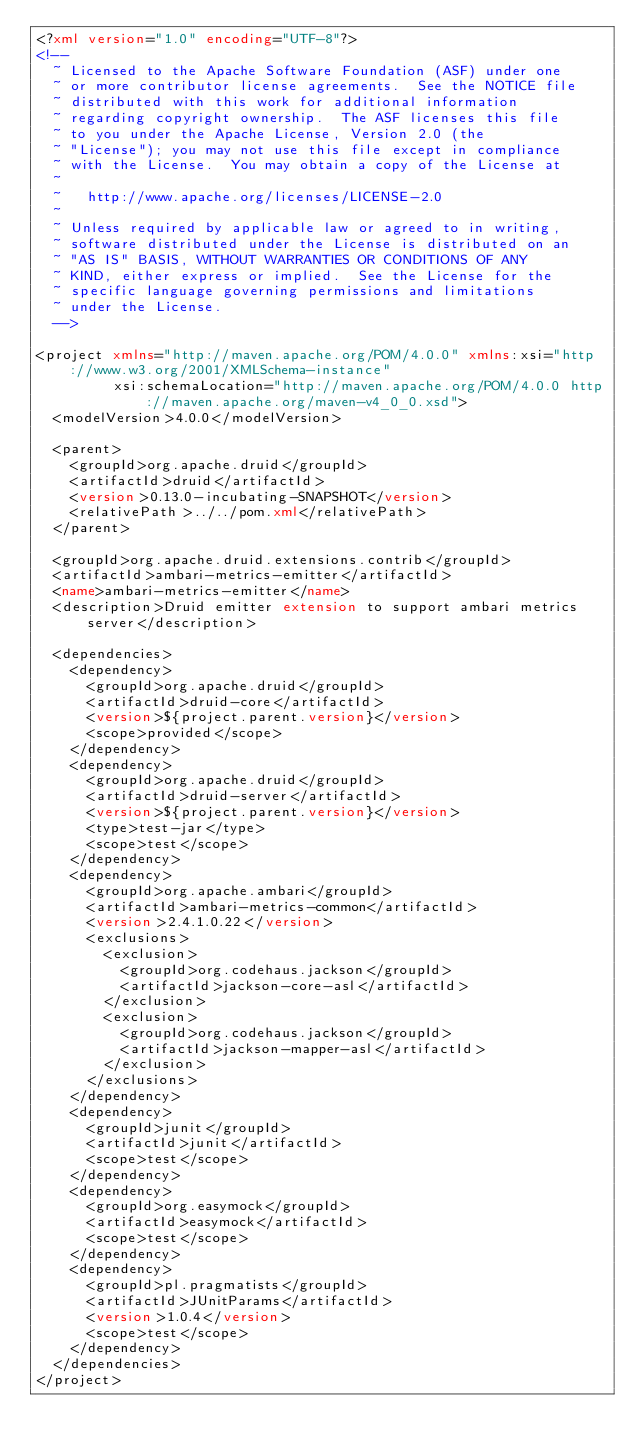Convert code to text. <code><loc_0><loc_0><loc_500><loc_500><_XML_><?xml version="1.0" encoding="UTF-8"?>
<!--
  ~ Licensed to the Apache Software Foundation (ASF) under one
  ~ or more contributor license agreements.  See the NOTICE file
  ~ distributed with this work for additional information
  ~ regarding copyright ownership.  The ASF licenses this file
  ~ to you under the Apache License, Version 2.0 (the
  ~ "License"); you may not use this file except in compliance
  ~ with the License.  You may obtain a copy of the License at
  ~
  ~   http://www.apache.org/licenses/LICENSE-2.0
  ~
  ~ Unless required by applicable law or agreed to in writing,
  ~ software distributed under the License is distributed on an
  ~ "AS IS" BASIS, WITHOUT WARRANTIES OR CONDITIONS OF ANY
  ~ KIND, either express or implied.  See the License for the
  ~ specific language governing permissions and limitations
  ~ under the License.
  -->

<project xmlns="http://maven.apache.org/POM/4.0.0" xmlns:xsi="http://www.w3.org/2001/XMLSchema-instance"
         xsi:schemaLocation="http://maven.apache.org/POM/4.0.0 http://maven.apache.org/maven-v4_0_0.xsd">
  <modelVersion>4.0.0</modelVersion>

  <parent>
    <groupId>org.apache.druid</groupId>
    <artifactId>druid</artifactId>
    <version>0.13.0-incubating-SNAPSHOT</version>
    <relativePath>../../pom.xml</relativePath>
  </parent>

  <groupId>org.apache.druid.extensions.contrib</groupId>
  <artifactId>ambari-metrics-emitter</artifactId>
  <name>ambari-metrics-emitter</name>
  <description>Druid emitter extension to support ambari metrics server</description>

  <dependencies>
    <dependency>
      <groupId>org.apache.druid</groupId>
      <artifactId>druid-core</artifactId>
      <version>${project.parent.version}</version>
      <scope>provided</scope>
    </dependency>
    <dependency>
      <groupId>org.apache.druid</groupId>
      <artifactId>druid-server</artifactId>
      <version>${project.parent.version}</version>
      <type>test-jar</type>
      <scope>test</scope>
    </dependency>
    <dependency>
      <groupId>org.apache.ambari</groupId>
      <artifactId>ambari-metrics-common</artifactId>
      <version>2.4.1.0.22</version>
      <exclusions>
        <exclusion>
          <groupId>org.codehaus.jackson</groupId>
          <artifactId>jackson-core-asl</artifactId>
        </exclusion>
        <exclusion>
          <groupId>org.codehaus.jackson</groupId>
          <artifactId>jackson-mapper-asl</artifactId>
        </exclusion>
      </exclusions>
    </dependency>
    <dependency>
      <groupId>junit</groupId>
      <artifactId>junit</artifactId>
      <scope>test</scope>
    </dependency>
    <dependency>
      <groupId>org.easymock</groupId>
      <artifactId>easymock</artifactId>
      <scope>test</scope>
    </dependency>
    <dependency>
      <groupId>pl.pragmatists</groupId>
      <artifactId>JUnitParams</artifactId>
      <version>1.0.4</version>
      <scope>test</scope>
    </dependency>
  </dependencies>
</project>
</code> 